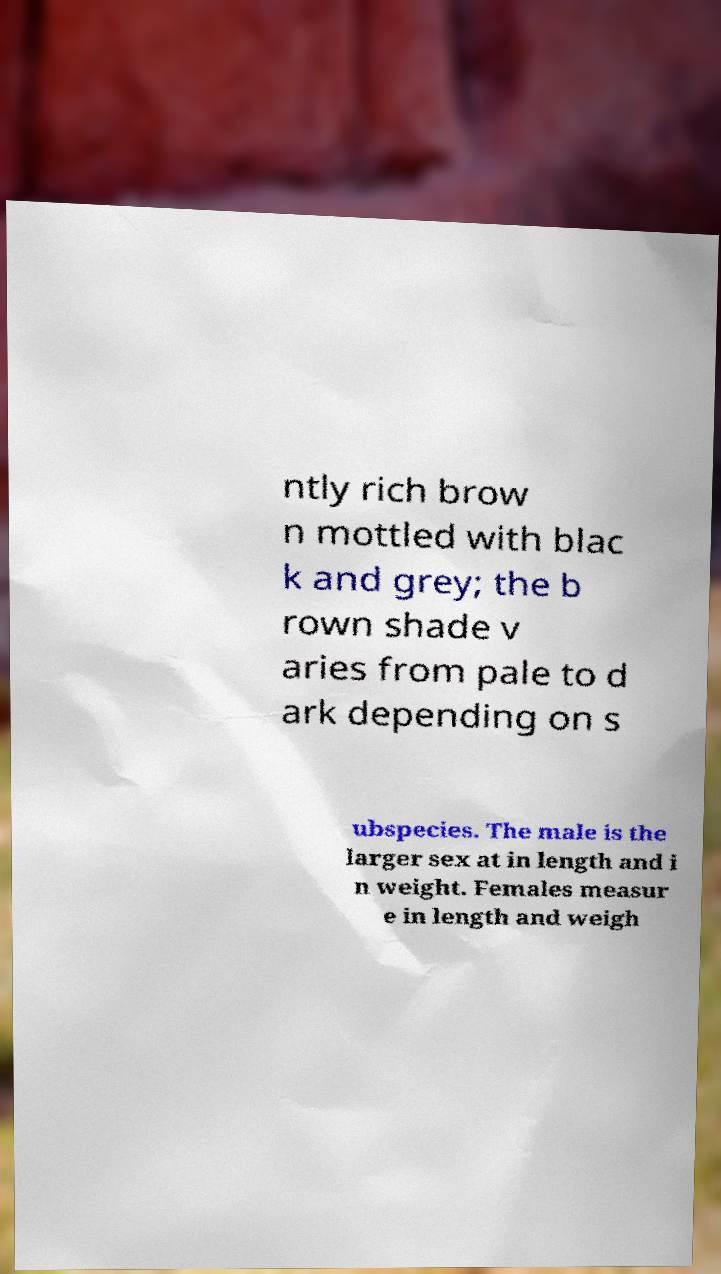For documentation purposes, I need the text within this image transcribed. Could you provide that? ntly rich brow n mottled with blac k and grey; the b rown shade v aries from pale to d ark depending on s ubspecies. The male is the larger sex at in length and i n weight. Females measur e in length and weigh 